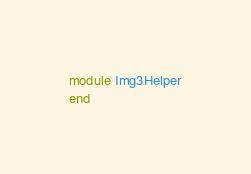<code> <loc_0><loc_0><loc_500><loc_500><_Ruby_>module Img3Helper
end
</code> 